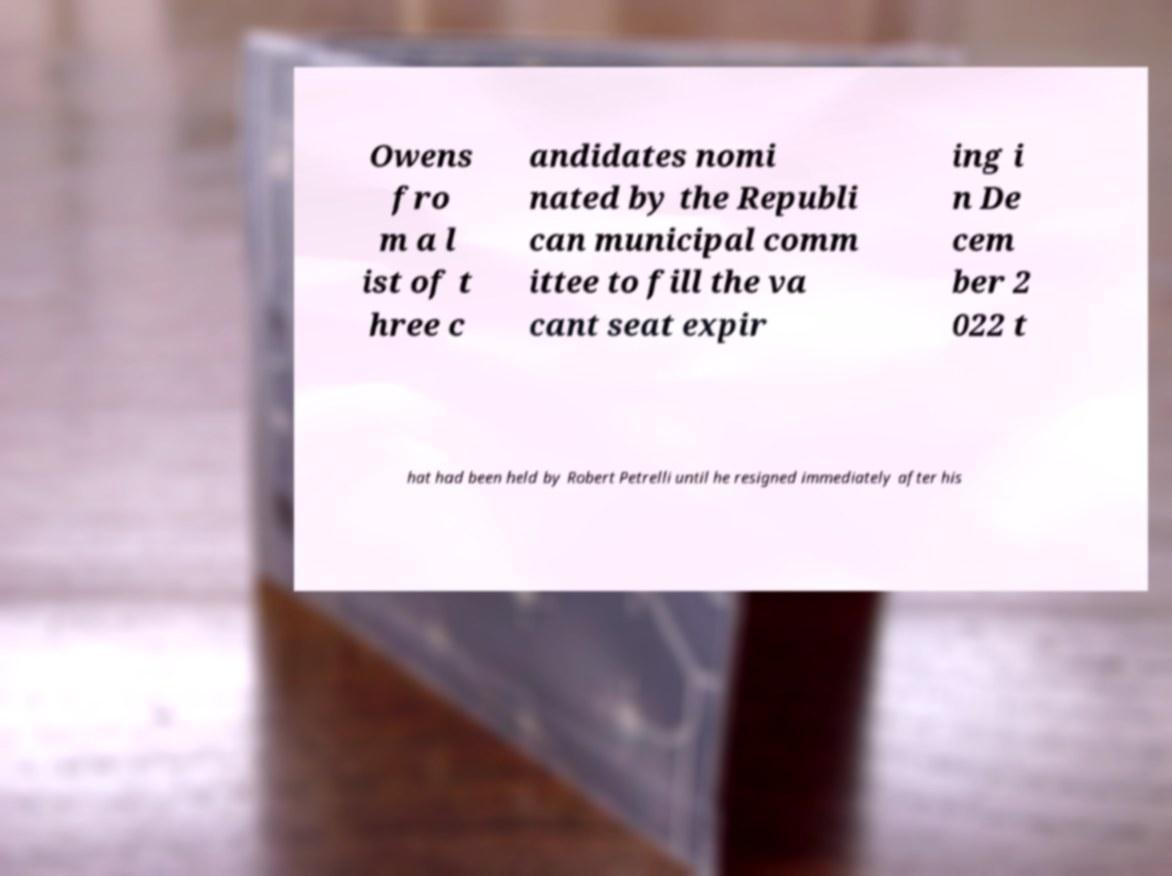I need the written content from this picture converted into text. Can you do that? Owens fro m a l ist of t hree c andidates nomi nated by the Republi can municipal comm ittee to fill the va cant seat expir ing i n De cem ber 2 022 t hat had been held by Robert Petrelli until he resigned immediately after his 